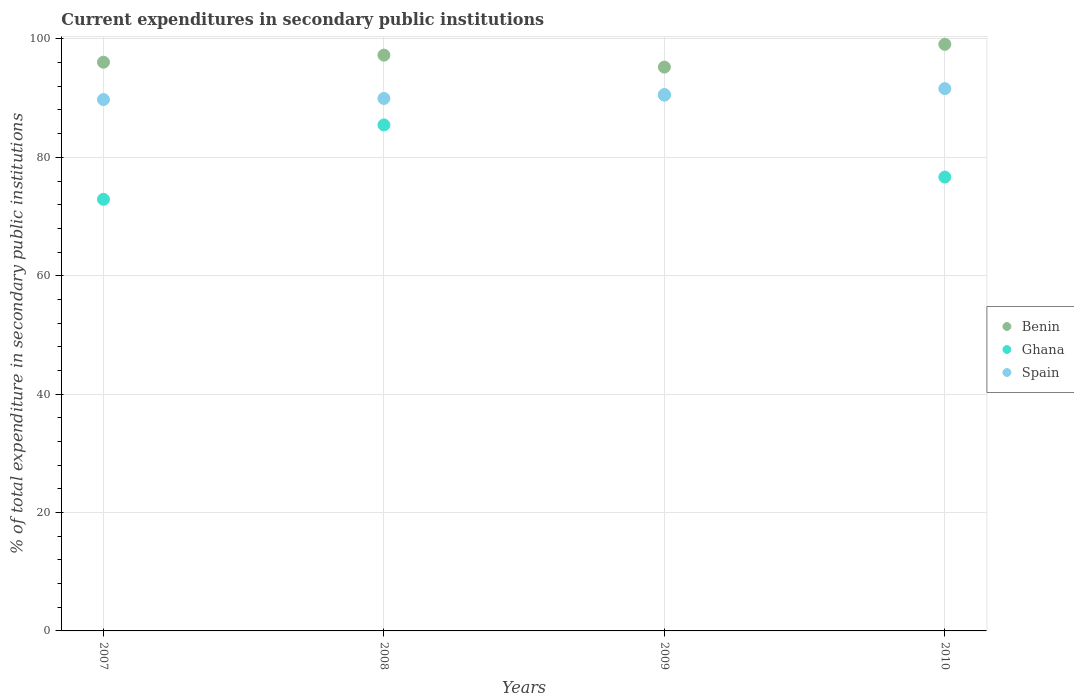How many different coloured dotlines are there?
Your answer should be compact. 3. What is the current expenditures in secondary public institutions in Ghana in 2007?
Offer a very short reply. 72.91. Across all years, what is the maximum current expenditures in secondary public institutions in Ghana?
Offer a very short reply. 90.52. Across all years, what is the minimum current expenditures in secondary public institutions in Ghana?
Offer a terse response. 72.91. In which year was the current expenditures in secondary public institutions in Benin minimum?
Ensure brevity in your answer.  2009. What is the total current expenditures in secondary public institutions in Ghana in the graph?
Offer a very short reply. 325.57. What is the difference between the current expenditures in secondary public institutions in Ghana in 2008 and that in 2010?
Offer a very short reply. 8.81. What is the difference between the current expenditures in secondary public institutions in Benin in 2009 and the current expenditures in secondary public institutions in Spain in 2010?
Give a very brief answer. 3.64. What is the average current expenditures in secondary public institutions in Ghana per year?
Your answer should be very brief. 81.39. In the year 2008, what is the difference between the current expenditures in secondary public institutions in Ghana and current expenditures in secondary public institutions in Spain?
Give a very brief answer. -4.47. In how many years, is the current expenditures in secondary public institutions in Ghana greater than 32 %?
Give a very brief answer. 4. What is the ratio of the current expenditures in secondary public institutions in Ghana in 2009 to that in 2010?
Make the answer very short. 1.18. Is the difference between the current expenditures in secondary public institutions in Ghana in 2007 and 2009 greater than the difference between the current expenditures in secondary public institutions in Spain in 2007 and 2009?
Keep it short and to the point. No. What is the difference between the highest and the second highest current expenditures in secondary public institutions in Benin?
Offer a terse response. 1.83. What is the difference between the highest and the lowest current expenditures in secondary public institutions in Spain?
Your response must be concise. 1.85. In how many years, is the current expenditures in secondary public institutions in Benin greater than the average current expenditures in secondary public institutions in Benin taken over all years?
Give a very brief answer. 2. Is it the case that in every year, the sum of the current expenditures in secondary public institutions in Spain and current expenditures in secondary public institutions in Ghana  is greater than the current expenditures in secondary public institutions in Benin?
Provide a short and direct response. Yes. Does the current expenditures in secondary public institutions in Benin monotonically increase over the years?
Keep it short and to the point. No. Are the values on the major ticks of Y-axis written in scientific E-notation?
Your response must be concise. No. Does the graph contain grids?
Your answer should be compact. Yes. How are the legend labels stacked?
Provide a short and direct response. Vertical. What is the title of the graph?
Your response must be concise. Current expenditures in secondary public institutions. What is the label or title of the Y-axis?
Keep it short and to the point. % of total expenditure in secondary public institutions. What is the % of total expenditure in secondary public institutions in Benin in 2007?
Your answer should be compact. 96.07. What is the % of total expenditure in secondary public institutions in Ghana in 2007?
Make the answer very short. 72.91. What is the % of total expenditure in secondary public institutions in Spain in 2007?
Ensure brevity in your answer.  89.76. What is the % of total expenditure in secondary public institutions of Benin in 2008?
Ensure brevity in your answer.  97.26. What is the % of total expenditure in secondary public institutions in Ghana in 2008?
Provide a succinct answer. 85.48. What is the % of total expenditure in secondary public institutions of Spain in 2008?
Offer a very short reply. 89.95. What is the % of total expenditure in secondary public institutions in Benin in 2009?
Provide a succinct answer. 95.25. What is the % of total expenditure in secondary public institutions of Ghana in 2009?
Provide a succinct answer. 90.52. What is the % of total expenditure in secondary public institutions in Spain in 2009?
Your answer should be compact. 90.61. What is the % of total expenditure in secondary public institutions of Benin in 2010?
Provide a succinct answer. 99.09. What is the % of total expenditure in secondary public institutions in Ghana in 2010?
Offer a very short reply. 76.67. What is the % of total expenditure in secondary public institutions of Spain in 2010?
Provide a short and direct response. 91.61. Across all years, what is the maximum % of total expenditure in secondary public institutions in Benin?
Provide a succinct answer. 99.09. Across all years, what is the maximum % of total expenditure in secondary public institutions in Ghana?
Keep it short and to the point. 90.52. Across all years, what is the maximum % of total expenditure in secondary public institutions in Spain?
Offer a very short reply. 91.61. Across all years, what is the minimum % of total expenditure in secondary public institutions of Benin?
Keep it short and to the point. 95.25. Across all years, what is the minimum % of total expenditure in secondary public institutions of Ghana?
Provide a succinct answer. 72.91. Across all years, what is the minimum % of total expenditure in secondary public institutions of Spain?
Ensure brevity in your answer.  89.76. What is the total % of total expenditure in secondary public institutions in Benin in the graph?
Your response must be concise. 387.68. What is the total % of total expenditure in secondary public institutions in Ghana in the graph?
Offer a terse response. 325.57. What is the total % of total expenditure in secondary public institutions of Spain in the graph?
Give a very brief answer. 361.92. What is the difference between the % of total expenditure in secondary public institutions in Benin in 2007 and that in 2008?
Offer a very short reply. -1.19. What is the difference between the % of total expenditure in secondary public institutions in Ghana in 2007 and that in 2008?
Offer a very short reply. -12.57. What is the difference between the % of total expenditure in secondary public institutions in Spain in 2007 and that in 2008?
Give a very brief answer. -0.19. What is the difference between the % of total expenditure in secondary public institutions of Benin in 2007 and that in 2009?
Make the answer very short. 0.82. What is the difference between the % of total expenditure in secondary public institutions in Ghana in 2007 and that in 2009?
Give a very brief answer. -17.61. What is the difference between the % of total expenditure in secondary public institutions in Spain in 2007 and that in 2009?
Offer a very short reply. -0.85. What is the difference between the % of total expenditure in secondary public institutions of Benin in 2007 and that in 2010?
Your response must be concise. -3.02. What is the difference between the % of total expenditure in secondary public institutions in Ghana in 2007 and that in 2010?
Ensure brevity in your answer.  -3.76. What is the difference between the % of total expenditure in secondary public institutions in Spain in 2007 and that in 2010?
Ensure brevity in your answer.  -1.85. What is the difference between the % of total expenditure in secondary public institutions in Benin in 2008 and that in 2009?
Make the answer very short. 2.02. What is the difference between the % of total expenditure in secondary public institutions in Ghana in 2008 and that in 2009?
Make the answer very short. -5.04. What is the difference between the % of total expenditure in secondary public institutions of Spain in 2008 and that in 2009?
Offer a terse response. -0.66. What is the difference between the % of total expenditure in secondary public institutions in Benin in 2008 and that in 2010?
Offer a very short reply. -1.83. What is the difference between the % of total expenditure in secondary public institutions in Ghana in 2008 and that in 2010?
Give a very brief answer. 8.81. What is the difference between the % of total expenditure in secondary public institutions in Spain in 2008 and that in 2010?
Ensure brevity in your answer.  -1.66. What is the difference between the % of total expenditure in secondary public institutions of Benin in 2009 and that in 2010?
Your answer should be very brief. -3.85. What is the difference between the % of total expenditure in secondary public institutions in Ghana in 2009 and that in 2010?
Provide a short and direct response. 13.85. What is the difference between the % of total expenditure in secondary public institutions of Spain in 2009 and that in 2010?
Ensure brevity in your answer.  -1. What is the difference between the % of total expenditure in secondary public institutions in Benin in 2007 and the % of total expenditure in secondary public institutions in Ghana in 2008?
Offer a terse response. 10.6. What is the difference between the % of total expenditure in secondary public institutions in Benin in 2007 and the % of total expenditure in secondary public institutions in Spain in 2008?
Your answer should be very brief. 6.12. What is the difference between the % of total expenditure in secondary public institutions of Ghana in 2007 and the % of total expenditure in secondary public institutions of Spain in 2008?
Make the answer very short. -17.04. What is the difference between the % of total expenditure in secondary public institutions of Benin in 2007 and the % of total expenditure in secondary public institutions of Ghana in 2009?
Offer a terse response. 5.55. What is the difference between the % of total expenditure in secondary public institutions in Benin in 2007 and the % of total expenditure in secondary public institutions in Spain in 2009?
Make the answer very short. 5.46. What is the difference between the % of total expenditure in secondary public institutions in Ghana in 2007 and the % of total expenditure in secondary public institutions in Spain in 2009?
Your response must be concise. -17.7. What is the difference between the % of total expenditure in secondary public institutions of Benin in 2007 and the % of total expenditure in secondary public institutions of Ghana in 2010?
Provide a short and direct response. 19.41. What is the difference between the % of total expenditure in secondary public institutions in Benin in 2007 and the % of total expenditure in secondary public institutions in Spain in 2010?
Offer a very short reply. 4.47. What is the difference between the % of total expenditure in secondary public institutions of Ghana in 2007 and the % of total expenditure in secondary public institutions of Spain in 2010?
Keep it short and to the point. -18.7. What is the difference between the % of total expenditure in secondary public institutions in Benin in 2008 and the % of total expenditure in secondary public institutions in Ghana in 2009?
Provide a succinct answer. 6.75. What is the difference between the % of total expenditure in secondary public institutions of Benin in 2008 and the % of total expenditure in secondary public institutions of Spain in 2009?
Your answer should be compact. 6.66. What is the difference between the % of total expenditure in secondary public institutions in Ghana in 2008 and the % of total expenditure in secondary public institutions in Spain in 2009?
Provide a succinct answer. -5.13. What is the difference between the % of total expenditure in secondary public institutions of Benin in 2008 and the % of total expenditure in secondary public institutions of Ghana in 2010?
Provide a succinct answer. 20.6. What is the difference between the % of total expenditure in secondary public institutions in Benin in 2008 and the % of total expenditure in secondary public institutions in Spain in 2010?
Offer a very short reply. 5.66. What is the difference between the % of total expenditure in secondary public institutions of Ghana in 2008 and the % of total expenditure in secondary public institutions of Spain in 2010?
Your answer should be compact. -6.13. What is the difference between the % of total expenditure in secondary public institutions of Benin in 2009 and the % of total expenditure in secondary public institutions of Ghana in 2010?
Offer a very short reply. 18.58. What is the difference between the % of total expenditure in secondary public institutions in Benin in 2009 and the % of total expenditure in secondary public institutions in Spain in 2010?
Your answer should be compact. 3.64. What is the difference between the % of total expenditure in secondary public institutions of Ghana in 2009 and the % of total expenditure in secondary public institutions of Spain in 2010?
Offer a terse response. -1.09. What is the average % of total expenditure in secondary public institutions of Benin per year?
Give a very brief answer. 96.92. What is the average % of total expenditure in secondary public institutions of Ghana per year?
Give a very brief answer. 81.39. What is the average % of total expenditure in secondary public institutions of Spain per year?
Your response must be concise. 90.48. In the year 2007, what is the difference between the % of total expenditure in secondary public institutions of Benin and % of total expenditure in secondary public institutions of Ghana?
Your answer should be very brief. 23.16. In the year 2007, what is the difference between the % of total expenditure in secondary public institutions of Benin and % of total expenditure in secondary public institutions of Spain?
Your response must be concise. 6.31. In the year 2007, what is the difference between the % of total expenditure in secondary public institutions of Ghana and % of total expenditure in secondary public institutions of Spain?
Make the answer very short. -16.85. In the year 2008, what is the difference between the % of total expenditure in secondary public institutions of Benin and % of total expenditure in secondary public institutions of Ghana?
Your answer should be compact. 11.79. In the year 2008, what is the difference between the % of total expenditure in secondary public institutions in Benin and % of total expenditure in secondary public institutions in Spain?
Make the answer very short. 7.32. In the year 2008, what is the difference between the % of total expenditure in secondary public institutions of Ghana and % of total expenditure in secondary public institutions of Spain?
Offer a very short reply. -4.47. In the year 2009, what is the difference between the % of total expenditure in secondary public institutions in Benin and % of total expenditure in secondary public institutions in Ghana?
Provide a succinct answer. 4.73. In the year 2009, what is the difference between the % of total expenditure in secondary public institutions in Benin and % of total expenditure in secondary public institutions in Spain?
Offer a very short reply. 4.64. In the year 2009, what is the difference between the % of total expenditure in secondary public institutions in Ghana and % of total expenditure in secondary public institutions in Spain?
Provide a short and direct response. -0.09. In the year 2010, what is the difference between the % of total expenditure in secondary public institutions of Benin and % of total expenditure in secondary public institutions of Ghana?
Give a very brief answer. 22.43. In the year 2010, what is the difference between the % of total expenditure in secondary public institutions of Benin and % of total expenditure in secondary public institutions of Spain?
Provide a succinct answer. 7.49. In the year 2010, what is the difference between the % of total expenditure in secondary public institutions in Ghana and % of total expenditure in secondary public institutions in Spain?
Offer a very short reply. -14.94. What is the ratio of the % of total expenditure in secondary public institutions in Ghana in 2007 to that in 2008?
Provide a succinct answer. 0.85. What is the ratio of the % of total expenditure in secondary public institutions of Spain in 2007 to that in 2008?
Provide a succinct answer. 1. What is the ratio of the % of total expenditure in secondary public institutions of Benin in 2007 to that in 2009?
Ensure brevity in your answer.  1.01. What is the ratio of the % of total expenditure in secondary public institutions of Ghana in 2007 to that in 2009?
Ensure brevity in your answer.  0.81. What is the ratio of the % of total expenditure in secondary public institutions in Spain in 2007 to that in 2009?
Give a very brief answer. 0.99. What is the ratio of the % of total expenditure in secondary public institutions of Benin in 2007 to that in 2010?
Keep it short and to the point. 0.97. What is the ratio of the % of total expenditure in secondary public institutions in Ghana in 2007 to that in 2010?
Ensure brevity in your answer.  0.95. What is the ratio of the % of total expenditure in secondary public institutions in Spain in 2007 to that in 2010?
Give a very brief answer. 0.98. What is the ratio of the % of total expenditure in secondary public institutions in Benin in 2008 to that in 2009?
Ensure brevity in your answer.  1.02. What is the ratio of the % of total expenditure in secondary public institutions in Ghana in 2008 to that in 2009?
Give a very brief answer. 0.94. What is the ratio of the % of total expenditure in secondary public institutions of Spain in 2008 to that in 2009?
Offer a terse response. 0.99. What is the ratio of the % of total expenditure in secondary public institutions of Benin in 2008 to that in 2010?
Provide a succinct answer. 0.98. What is the ratio of the % of total expenditure in secondary public institutions of Ghana in 2008 to that in 2010?
Provide a short and direct response. 1.11. What is the ratio of the % of total expenditure in secondary public institutions in Spain in 2008 to that in 2010?
Give a very brief answer. 0.98. What is the ratio of the % of total expenditure in secondary public institutions of Benin in 2009 to that in 2010?
Give a very brief answer. 0.96. What is the ratio of the % of total expenditure in secondary public institutions in Ghana in 2009 to that in 2010?
Offer a very short reply. 1.18. What is the difference between the highest and the second highest % of total expenditure in secondary public institutions of Benin?
Provide a short and direct response. 1.83. What is the difference between the highest and the second highest % of total expenditure in secondary public institutions in Ghana?
Offer a very short reply. 5.04. What is the difference between the highest and the lowest % of total expenditure in secondary public institutions in Benin?
Give a very brief answer. 3.85. What is the difference between the highest and the lowest % of total expenditure in secondary public institutions of Ghana?
Provide a succinct answer. 17.61. What is the difference between the highest and the lowest % of total expenditure in secondary public institutions of Spain?
Provide a short and direct response. 1.85. 